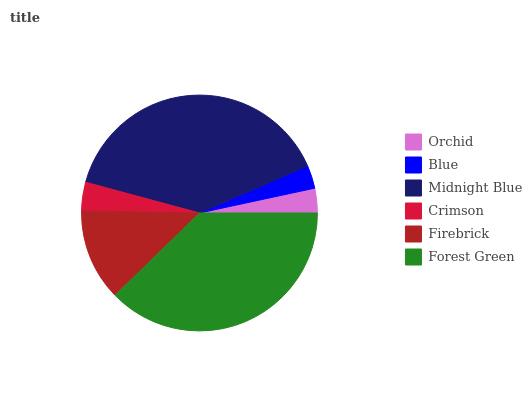Is Blue the minimum?
Answer yes or no. Yes. Is Midnight Blue the maximum?
Answer yes or no. Yes. Is Midnight Blue the minimum?
Answer yes or no. No. Is Blue the maximum?
Answer yes or no. No. Is Midnight Blue greater than Blue?
Answer yes or no. Yes. Is Blue less than Midnight Blue?
Answer yes or no. Yes. Is Blue greater than Midnight Blue?
Answer yes or no. No. Is Midnight Blue less than Blue?
Answer yes or no. No. Is Firebrick the high median?
Answer yes or no. Yes. Is Crimson the low median?
Answer yes or no. Yes. Is Blue the high median?
Answer yes or no. No. Is Forest Green the low median?
Answer yes or no. No. 